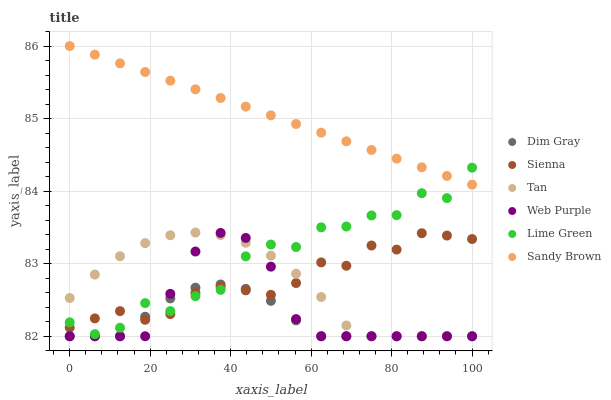Does Dim Gray have the minimum area under the curve?
Answer yes or no. Yes. Does Sandy Brown have the maximum area under the curve?
Answer yes or no. Yes. Does Lime Green have the minimum area under the curve?
Answer yes or no. No. Does Lime Green have the maximum area under the curve?
Answer yes or no. No. Is Sandy Brown the smoothest?
Answer yes or no. Yes. Is Lime Green the roughest?
Answer yes or no. Yes. Is Sienna the smoothest?
Answer yes or no. No. Is Sienna the roughest?
Answer yes or no. No. Does Dim Gray have the lowest value?
Answer yes or no. Yes. Does Lime Green have the lowest value?
Answer yes or no. No. Does Sandy Brown have the highest value?
Answer yes or no. Yes. Does Lime Green have the highest value?
Answer yes or no. No. Is Sienna less than Sandy Brown?
Answer yes or no. Yes. Is Sandy Brown greater than Dim Gray?
Answer yes or no. Yes. Does Sandy Brown intersect Lime Green?
Answer yes or no. Yes. Is Sandy Brown less than Lime Green?
Answer yes or no. No. Is Sandy Brown greater than Lime Green?
Answer yes or no. No. Does Sienna intersect Sandy Brown?
Answer yes or no. No. 